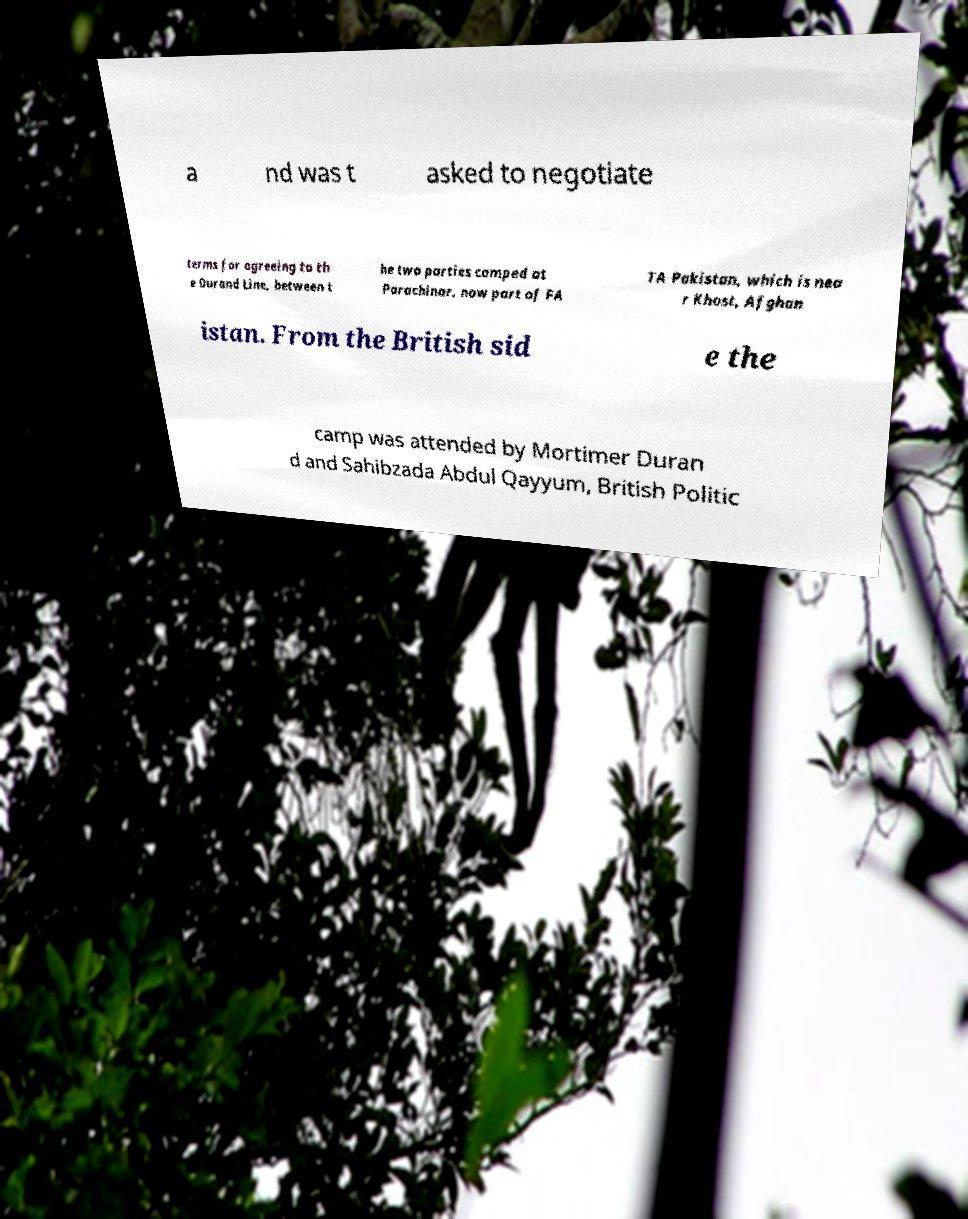I need the written content from this picture converted into text. Can you do that? a nd was t asked to negotiate terms for agreeing to th e Durand Line, between t he two parties camped at Parachinar, now part of FA TA Pakistan, which is nea r Khost, Afghan istan. From the British sid e the camp was attended by Mortimer Duran d and Sahibzada Abdul Qayyum, British Politic 